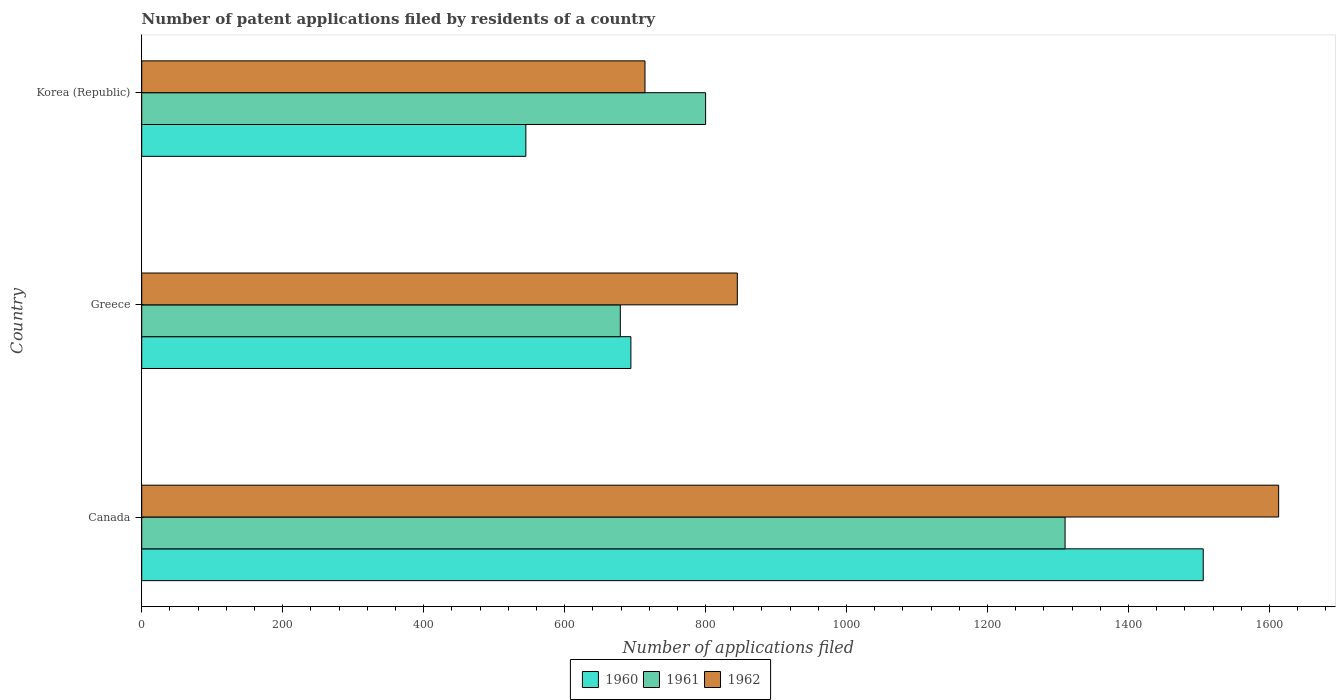How many groups of bars are there?
Your answer should be compact. 3. Are the number of bars per tick equal to the number of legend labels?
Your response must be concise. Yes. How many bars are there on the 3rd tick from the top?
Provide a succinct answer. 3. How many bars are there on the 2nd tick from the bottom?
Provide a succinct answer. 3. What is the number of applications filed in 1961 in Greece?
Your answer should be very brief. 679. Across all countries, what is the maximum number of applications filed in 1960?
Your answer should be very brief. 1506. Across all countries, what is the minimum number of applications filed in 1962?
Give a very brief answer. 714. In which country was the number of applications filed in 1961 minimum?
Your answer should be very brief. Greece. What is the total number of applications filed in 1960 in the graph?
Make the answer very short. 2745. What is the difference between the number of applications filed in 1960 in Canada and that in Korea (Republic)?
Keep it short and to the point. 961. What is the difference between the number of applications filed in 1962 in Greece and the number of applications filed in 1960 in Korea (Republic)?
Offer a very short reply. 300. What is the average number of applications filed in 1962 per country?
Make the answer very short. 1057.33. What is the difference between the number of applications filed in 1961 and number of applications filed in 1960 in Korea (Republic)?
Your answer should be very brief. 255. What is the ratio of the number of applications filed in 1960 in Canada to that in Korea (Republic)?
Provide a succinct answer. 2.76. Is the number of applications filed in 1962 in Greece less than that in Korea (Republic)?
Make the answer very short. No. What is the difference between the highest and the second highest number of applications filed in 1961?
Give a very brief answer. 510. What is the difference between the highest and the lowest number of applications filed in 1960?
Provide a short and direct response. 961. What does the 1st bar from the bottom in Korea (Republic) represents?
Your answer should be very brief. 1960. Is it the case that in every country, the sum of the number of applications filed in 1961 and number of applications filed in 1960 is greater than the number of applications filed in 1962?
Make the answer very short. Yes. Are all the bars in the graph horizontal?
Offer a very short reply. Yes. How many countries are there in the graph?
Make the answer very short. 3. What is the difference between two consecutive major ticks on the X-axis?
Provide a short and direct response. 200. Are the values on the major ticks of X-axis written in scientific E-notation?
Offer a terse response. No. Does the graph contain any zero values?
Your answer should be compact. No. Does the graph contain grids?
Ensure brevity in your answer.  No. Where does the legend appear in the graph?
Provide a succinct answer. Bottom center. What is the title of the graph?
Your answer should be very brief. Number of patent applications filed by residents of a country. Does "2004" appear as one of the legend labels in the graph?
Ensure brevity in your answer.  No. What is the label or title of the X-axis?
Ensure brevity in your answer.  Number of applications filed. What is the Number of applications filed in 1960 in Canada?
Give a very brief answer. 1506. What is the Number of applications filed in 1961 in Canada?
Provide a short and direct response. 1310. What is the Number of applications filed of 1962 in Canada?
Keep it short and to the point. 1613. What is the Number of applications filed of 1960 in Greece?
Offer a terse response. 694. What is the Number of applications filed in 1961 in Greece?
Offer a terse response. 679. What is the Number of applications filed of 1962 in Greece?
Your answer should be very brief. 845. What is the Number of applications filed in 1960 in Korea (Republic)?
Make the answer very short. 545. What is the Number of applications filed of 1961 in Korea (Republic)?
Your response must be concise. 800. What is the Number of applications filed in 1962 in Korea (Republic)?
Keep it short and to the point. 714. Across all countries, what is the maximum Number of applications filed in 1960?
Your response must be concise. 1506. Across all countries, what is the maximum Number of applications filed in 1961?
Provide a succinct answer. 1310. Across all countries, what is the maximum Number of applications filed in 1962?
Provide a short and direct response. 1613. Across all countries, what is the minimum Number of applications filed in 1960?
Provide a succinct answer. 545. Across all countries, what is the minimum Number of applications filed in 1961?
Your answer should be very brief. 679. Across all countries, what is the minimum Number of applications filed in 1962?
Offer a terse response. 714. What is the total Number of applications filed in 1960 in the graph?
Ensure brevity in your answer.  2745. What is the total Number of applications filed of 1961 in the graph?
Give a very brief answer. 2789. What is the total Number of applications filed in 1962 in the graph?
Offer a terse response. 3172. What is the difference between the Number of applications filed in 1960 in Canada and that in Greece?
Your answer should be very brief. 812. What is the difference between the Number of applications filed in 1961 in Canada and that in Greece?
Your answer should be compact. 631. What is the difference between the Number of applications filed of 1962 in Canada and that in Greece?
Keep it short and to the point. 768. What is the difference between the Number of applications filed in 1960 in Canada and that in Korea (Republic)?
Ensure brevity in your answer.  961. What is the difference between the Number of applications filed in 1961 in Canada and that in Korea (Republic)?
Your response must be concise. 510. What is the difference between the Number of applications filed of 1962 in Canada and that in Korea (Republic)?
Your response must be concise. 899. What is the difference between the Number of applications filed of 1960 in Greece and that in Korea (Republic)?
Provide a succinct answer. 149. What is the difference between the Number of applications filed of 1961 in Greece and that in Korea (Republic)?
Ensure brevity in your answer.  -121. What is the difference between the Number of applications filed in 1962 in Greece and that in Korea (Republic)?
Provide a short and direct response. 131. What is the difference between the Number of applications filed in 1960 in Canada and the Number of applications filed in 1961 in Greece?
Give a very brief answer. 827. What is the difference between the Number of applications filed of 1960 in Canada and the Number of applications filed of 1962 in Greece?
Offer a very short reply. 661. What is the difference between the Number of applications filed in 1961 in Canada and the Number of applications filed in 1962 in Greece?
Provide a succinct answer. 465. What is the difference between the Number of applications filed in 1960 in Canada and the Number of applications filed in 1961 in Korea (Republic)?
Your answer should be compact. 706. What is the difference between the Number of applications filed of 1960 in Canada and the Number of applications filed of 1962 in Korea (Republic)?
Offer a very short reply. 792. What is the difference between the Number of applications filed of 1961 in Canada and the Number of applications filed of 1962 in Korea (Republic)?
Offer a terse response. 596. What is the difference between the Number of applications filed of 1960 in Greece and the Number of applications filed of 1961 in Korea (Republic)?
Provide a succinct answer. -106. What is the difference between the Number of applications filed of 1960 in Greece and the Number of applications filed of 1962 in Korea (Republic)?
Your answer should be compact. -20. What is the difference between the Number of applications filed of 1961 in Greece and the Number of applications filed of 1962 in Korea (Republic)?
Offer a very short reply. -35. What is the average Number of applications filed of 1960 per country?
Your answer should be compact. 915. What is the average Number of applications filed in 1961 per country?
Your answer should be compact. 929.67. What is the average Number of applications filed in 1962 per country?
Give a very brief answer. 1057.33. What is the difference between the Number of applications filed of 1960 and Number of applications filed of 1961 in Canada?
Keep it short and to the point. 196. What is the difference between the Number of applications filed in 1960 and Number of applications filed in 1962 in Canada?
Your answer should be very brief. -107. What is the difference between the Number of applications filed in 1961 and Number of applications filed in 1962 in Canada?
Your response must be concise. -303. What is the difference between the Number of applications filed in 1960 and Number of applications filed in 1962 in Greece?
Give a very brief answer. -151. What is the difference between the Number of applications filed in 1961 and Number of applications filed in 1962 in Greece?
Give a very brief answer. -166. What is the difference between the Number of applications filed of 1960 and Number of applications filed of 1961 in Korea (Republic)?
Your answer should be compact. -255. What is the difference between the Number of applications filed of 1960 and Number of applications filed of 1962 in Korea (Republic)?
Offer a very short reply. -169. What is the difference between the Number of applications filed in 1961 and Number of applications filed in 1962 in Korea (Republic)?
Ensure brevity in your answer.  86. What is the ratio of the Number of applications filed of 1960 in Canada to that in Greece?
Keep it short and to the point. 2.17. What is the ratio of the Number of applications filed of 1961 in Canada to that in Greece?
Make the answer very short. 1.93. What is the ratio of the Number of applications filed in 1962 in Canada to that in Greece?
Your answer should be compact. 1.91. What is the ratio of the Number of applications filed in 1960 in Canada to that in Korea (Republic)?
Offer a very short reply. 2.76. What is the ratio of the Number of applications filed of 1961 in Canada to that in Korea (Republic)?
Ensure brevity in your answer.  1.64. What is the ratio of the Number of applications filed in 1962 in Canada to that in Korea (Republic)?
Make the answer very short. 2.26. What is the ratio of the Number of applications filed of 1960 in Greece to that in Korea (Republic)?
Give a very brief answer. 1.27. What is the ratio of the Number of applications filed in 1961 in Greece to that in Korea (Republic)?
Make the answer very short. 0.85. What is the ratio of the Number of applications filed of 1962 in Greece to that in Korea (Republic)?
Provide a succinct answer. 1.18. What is the difference between the highest and the second highest Number of applications filed in 1960?
Make the answer very short. 812. What is the difference between the highest and the second highest Number of applications filed in 1961?
Provide a succinct answer. 510. What is the difference between the highest and the second highest Number of applications filed in 1962?
Your response must be concise. 768. What is the difference between the highest and the lowest Number of applications filed of 1960?
Your response must be concise. 961. What is the difference between the highest and the lowest Number of applications filed of 1961?
Your answer should be compact. 631. What is the difference between the highest and the lowest Number of applications filed in 1962?
Offer a very short reply. 899. 